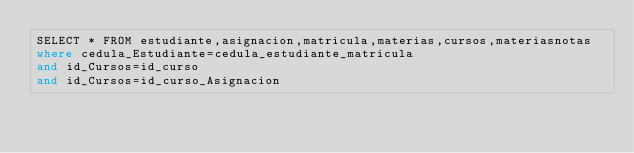<code> <loc_0><loc_0><loc_500><loc_500><_SQL_>SELECT * FROM estudiante,asignacion,matricula,materias,cursos,materiasnotas
where cedula_Estudiante=cedula_estudiante_matricula
and id_Cursos=id_curso
and id_Cursos=id_curso_Asignacion</code> 